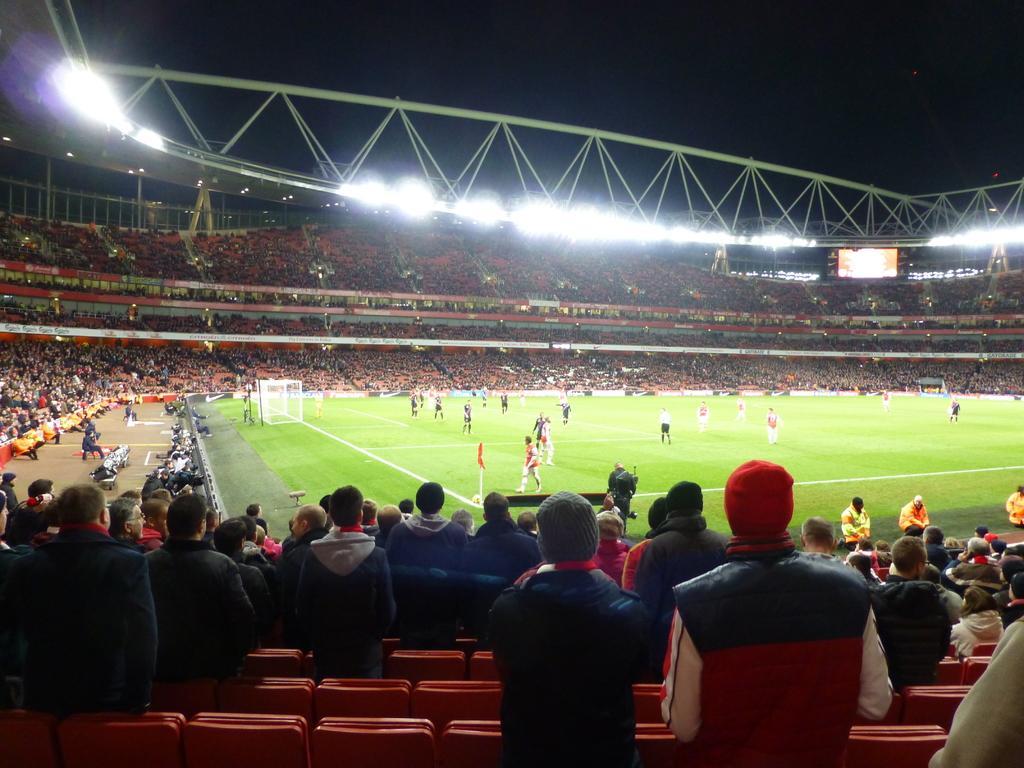Please provide a concise description of this image. This picture might be taken in a stadium, in this image in the center there are some people who are playing something. And there are a group of people who are sitting and watching the game, and also there are some chairs, lights and some screens and some other objects. At the top there is sky. 